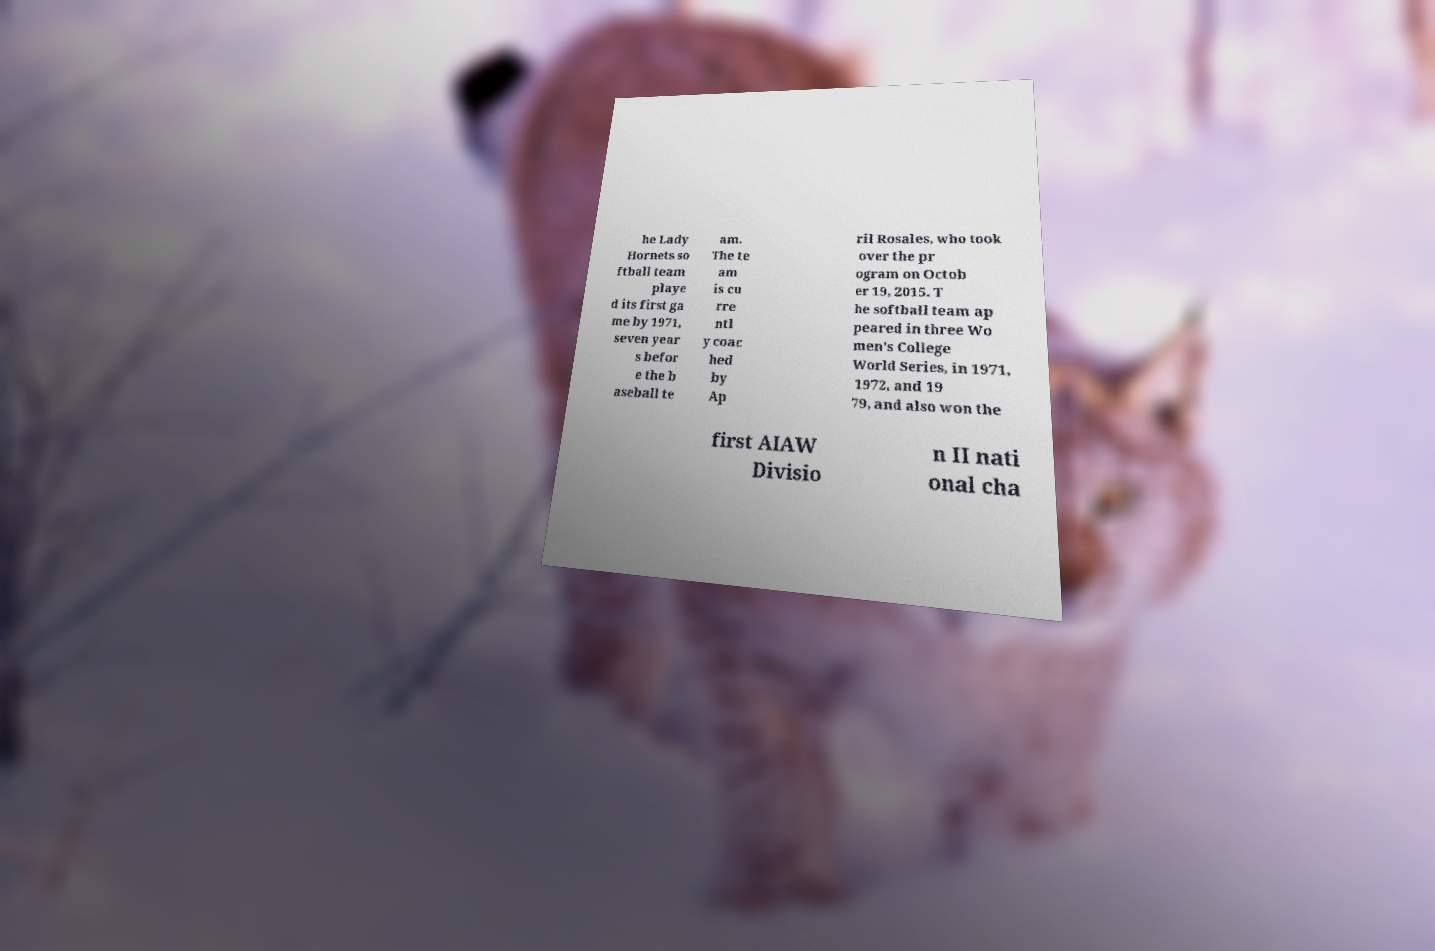There's text embedded in this image that I need extracted. Can you transcribe it verbatim? he Lady Hornets so ftball team playe d its first ga me by 1971, seven year s befor e the b aseball te am. The te am is cu rre ntl y coac hed by Ap ril Rosales, who took over the pr ogram on Octob er 19, 2015. T he softball team ap peared in three Wo men's College World Series, in 1971, 1972, and 19 79, and also won the first AIAW Divisio n II nati onal cha 